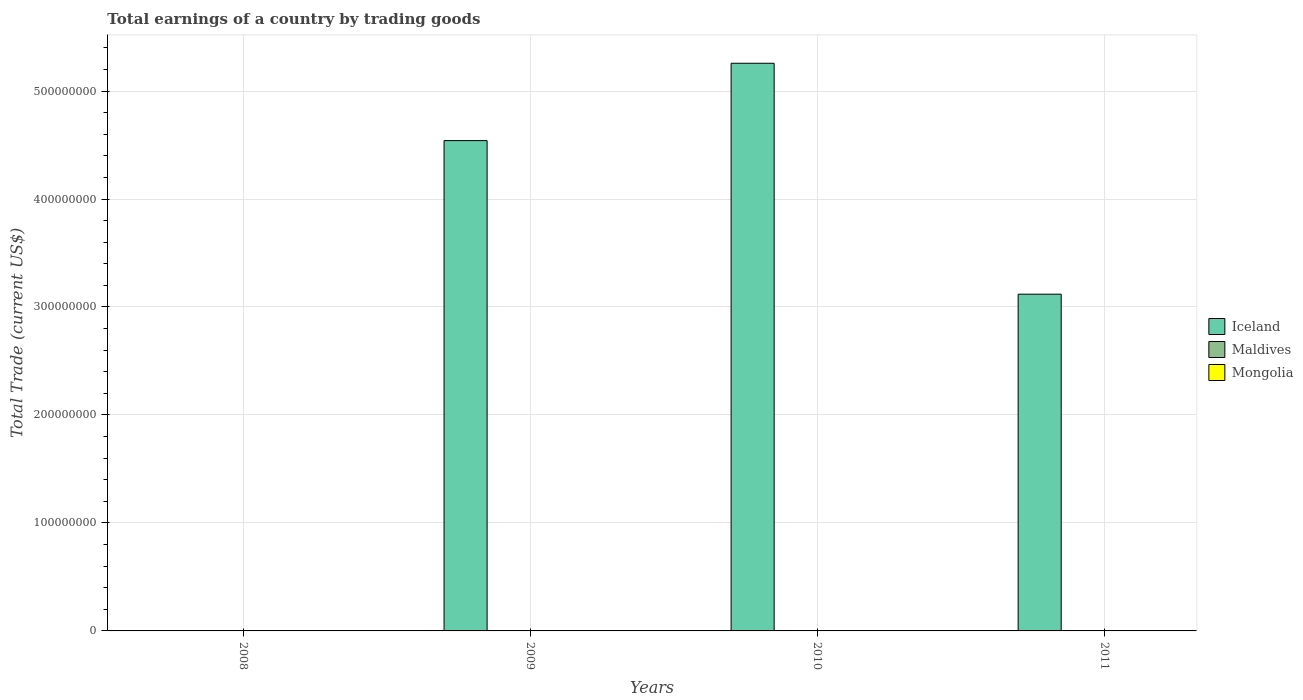How many different coloured bars are there?
Your answer should be very brief. 1. Are the number of bars on each tick of the X-axis equal?
Give a very brief answer. No. How many bars are there on the 4th tick from the left?
Keep it short and to the point. 1. How many bars are there on the 2nd tick from the right?
Offer a very short reply. 1. What is the total earnings in Mongolia in 2009?
Offer a very short reply. 0. Across all years, what is the maximum total earnings in Iceland?
Your answer should be very brief. 5.26e+08. In which year was the total earnings in Iceland maximum?
Provide a short and direct response. 2010. What is the total total earnings in Mongolia in the graph?
Your answer should be compact. 0. What is the difference between the total earnings in Iceland in 2010 and that in 2011?
Provide a succinct answer. 2.14e+08. What is the difference between the total earnings in Mongolia in 2008 and the total earnings in Iceland in 2009?
Provide a succinct answer. -4.54e+08. What is the average total earnings in Maldives per year?
Give a very brief answer. 0. Is the total earnings in Iceland in 2009 less than that in 2010?
Your answer should be compact. Yes. What is the difference between the highest and the second highest total earnings in Iceland?
Provide a short and direct response. 7.16e+07. What is the difference between the highest and the lowest total earnings in Iceland?
Give a very brief answer. 5.26e+08. Is the sum of the total earnings in Iceland in 2009 and 2010 greater than the maximum total earnings in Mongolia across all years?
Your answer should be compact. Yes. How many bars are there?
Your answer should be very brief. 3. Are all the bars in the graph horizontal?
Ensure brevity in your answer.  No. Are the values on the major ticks of Y-axis written in scientific E-notation?
Ensure brevity in your answer.  No. Where does the legend appear in the graph?
Your answer should be very brief. Center right. How are the legend labels stacked?
Ensure brevity in your answer.  Vertical. What is the title of the graph?
Ensure brevity in your answer.  Total earnings of a country by trading goods. What is the label or title of the Y-axis?
Offer a very short reply. Total Trade (current US$). What is the Total Trade (current US$) in Iceland in 2009?
Give a very brief answer. 4.54e+08. What is the Total Trade (current US$) of Maldives in 2009?
Offer a very short reply. 0. What is the Total Trade (current US$) of Iceland in 2010?
Give a very brief answer. 5.26e+08. What is the Total Trade (current US$) of Mongolia in 2010?
Your answer should be compact. 0. What is the Total Trade (current US$) in Iceland in 2011?
Provide a short and direct response. 3.12e+08. What is the Total Trade (current US$) of Mongolia in 2011?
Provide a short and direct response. 0. Across all years, what is the maximum Total Trade (current US$) of Iceland?
Ensure brevity in your answer.  5.26e+08. Across all years, what is the minimum Total Trade (current US$) of Iceland?
Give a very brief answer. 0. What is the total Total Trade (current US$) of Iceland in the graph?
Keep it short and to the point. 1.29e+09. What is the total Total Trade (current US$) in Mongolia in the graph?
Provide a short and direct response. 0. What is the difference between the Total Trade (current US$) of Iceland in 2009 and that in 2010?
Keep it short and to the point. -7.16e+07. What is the difference between the Total Trade (current US$) in Iceland in 2009 and that in 2011?
Your answer should be very brief. 1.42e+08. What is the difference between the Total Trade (current US$) of Iceland in 2010 and that in 2011?
Offer a very short reply. 2.14e+08. What is the average Total Trade (current US$) in Iceland per year?
Give a very brief answer. 3.23e+08. What is the average Total Trade (current US$) in Maldives per year?
Your response must be concise. 0. What is the average Total Trade (current US$) of Mongolia per year?
Give a very brief answer. 0. What is the ratio of the Total Trade (current US$) in Iceland in 2009 to that in 2010?
Give a very brief answer. 0.86. What is the ratio of the Total Trade (current US$) of Iceland in 2009 to that in 2011?
Your answer should be compact. 1.46. What is the ratio of the Total Trade (current US$) of Iceland in 2010 to that in 2011?
Your response must be concise. 1.69. What is the difference between the highest and the second highest Total Trade (current US$) of Iceland?
Offer a very short reply. 7.16e+07. What is the difference between the highest and the lowest Total Trade (current US$) of Iceland?
Your answer should be compact. 5.26e+08. 